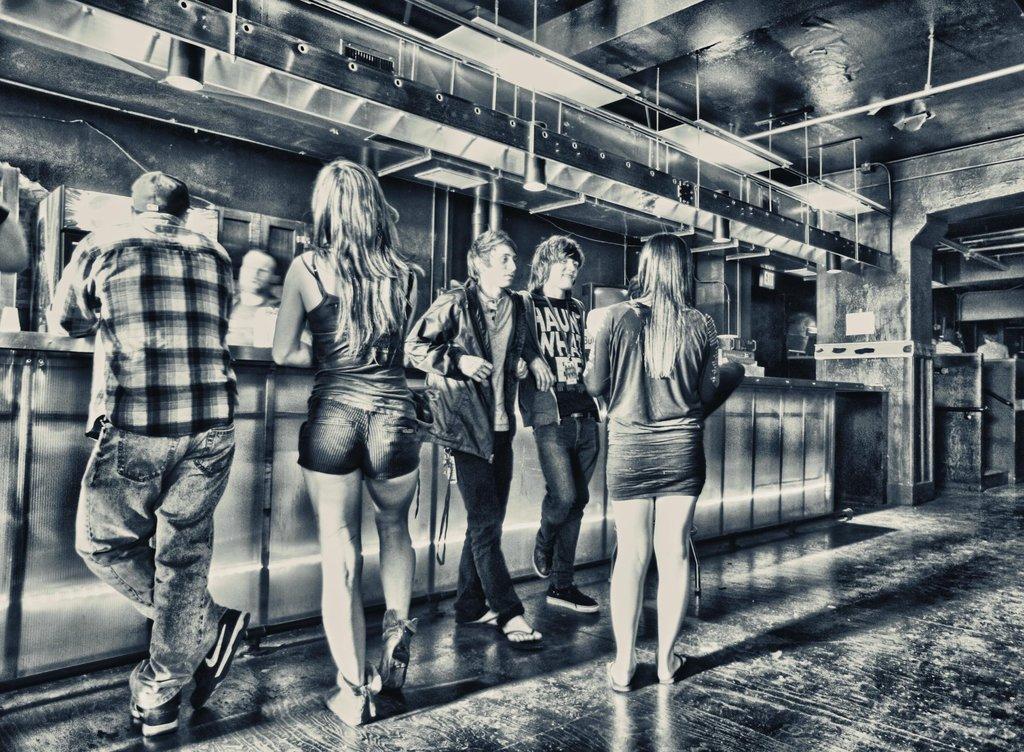Describe this image in one or two sentences. This looks like an edited image. I can see five people standing. This is a kind of a table. Here is another person standing. I think these are the lights and few other objects hanging to the ceiling. This is the floor. 